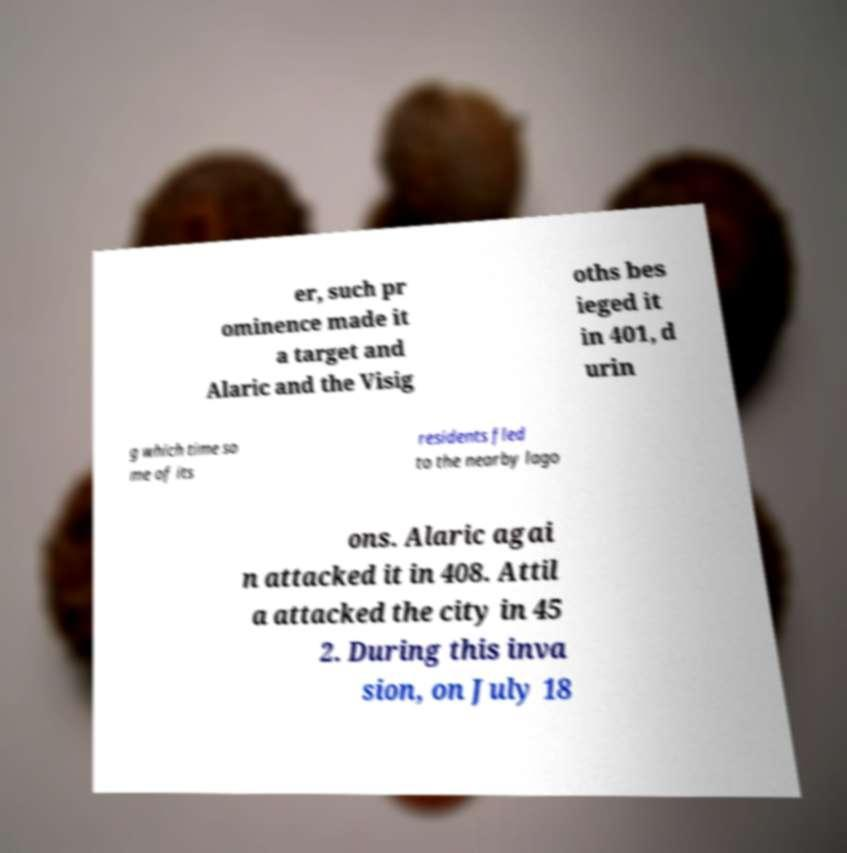For documentation purposes, I need the text within this image transcribed. Could you provide that? er, such pr ominence made it a target and Alaric and the Visig oths bes ieged it in 401, d urin g which time so me of its residents fled to the nearby lago ons. Alaric agai n attacked it in 408. Attil a attacked the city in 45 2. During this inva sion, on July 18 